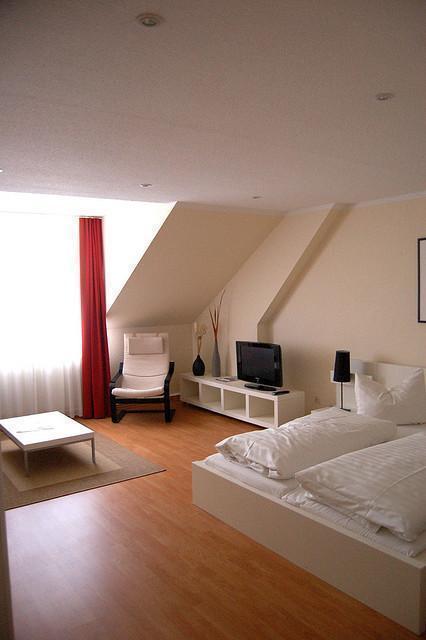How many watts does a night lamp use?
Indicate the correct response and explain using: 'Answer: answer
Rationale: rationale.'
Options: 3-7.5, 5-10, 1-2, 2.5-3.5. Answer: 3-7.5.
Rationale: It depends on the type of bulb. 